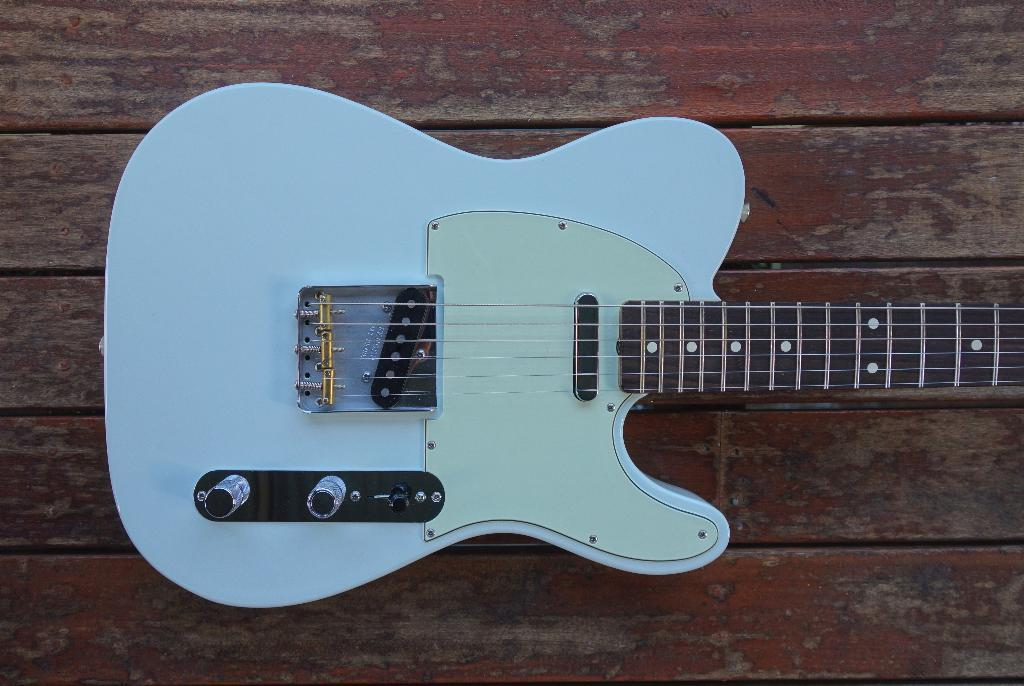What musical instrument is in the image? There is a guitar in the image. How is the guitar positioned in the image? The guitar is placed on a wooden plank. What are the guitar's components that produce sound? The guitar has strings. What are the guitar's components that connect to an amplifier? The guitar has cords. What are the guitar's components that adjust the sound? The guitar has knobs. What type of coil is used for arithmetic calculations in the image? There is no coil or arithmetic calculations present in the image; it features a guitar on a wooden plank. 